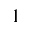Convert formula to latex. <formula><loc_0><loc_0><loc_500><loc_500>1</formula> 